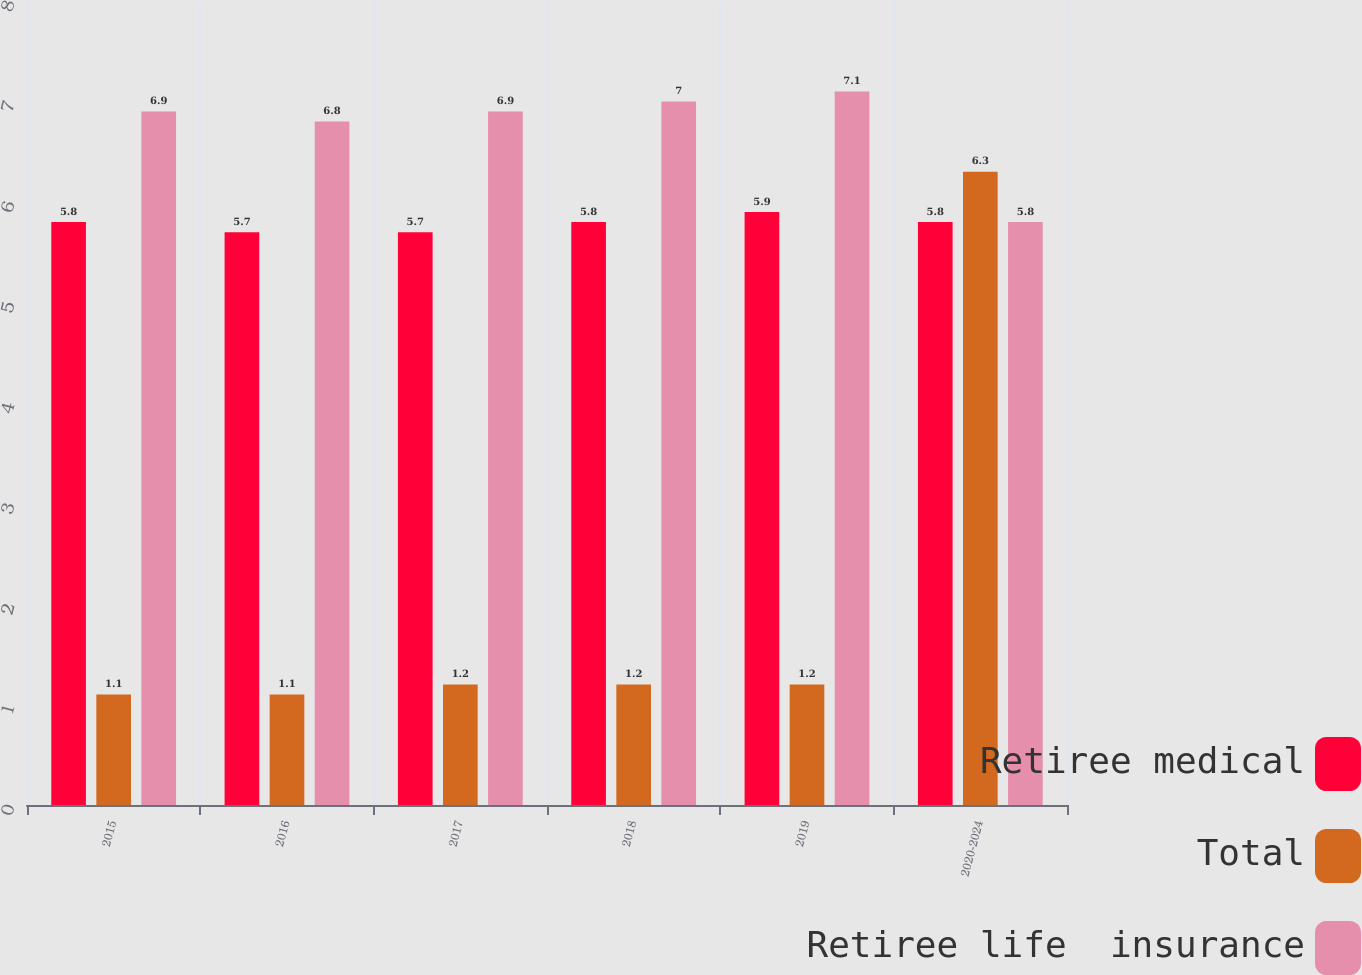Convert chart. <chart><loc_0><loc_0><loc_500><loc_500><stacked_bar_chart><ecel><fcel>2015<fcel>2016<fcel>2017<fcel>2018<fcel>2019<fcel>2020-2024<nl><fcel>Retiree medical<fcel>5.8<fcel>5.7<fcel>5.7<fcel>5.8<fcel>5.9<fcel>5.8<nl><fcel>Total<fcel>1.1<fcel>1.1<fcel>1.2<fcel>1.2<fcel>1.2<fcel>6.3<nl><fcel>Retiree life  insurance<fcel>6.9<fcel>6.8<fcel>6.9<fcel>7<fcel>7.1<fcel>5.8<nl></chart> 